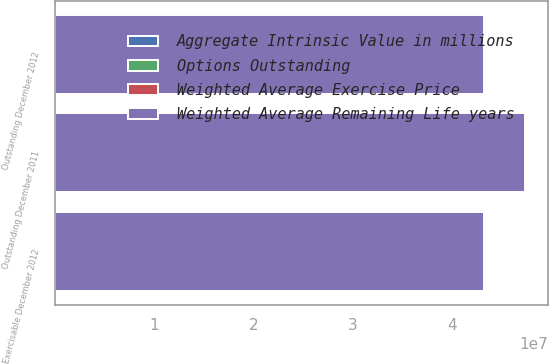Convert chart. <chart><loc_0><loc_0><loc_500><loc_500><stacked_bar_chart><ecel><fcel>Outstanding December 2011<fcel>Outstanding December 2012<fcel>Exercisable December 2012<nl><fcel>Weighted Average Remaining Life years<fcel>4.72569e+07<fcel>4.32171e+07<fcel>4.32038e+07<nl><fcel>Aggregate Intrinsic Value in millions<fcel>97.76<fcel>99.51<fcel>99.49<nl><fcel>Weighted Average Exercise Price<fcel>444<fcel>1672<fcel>1672<nl><fcel>Options Outstanding<fcel>6.08<fcel>5.55<fcel>5.55<nl></chart> 